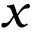<formula> <loc_0><loc_0><loc_500><loc_500>x</formula> 